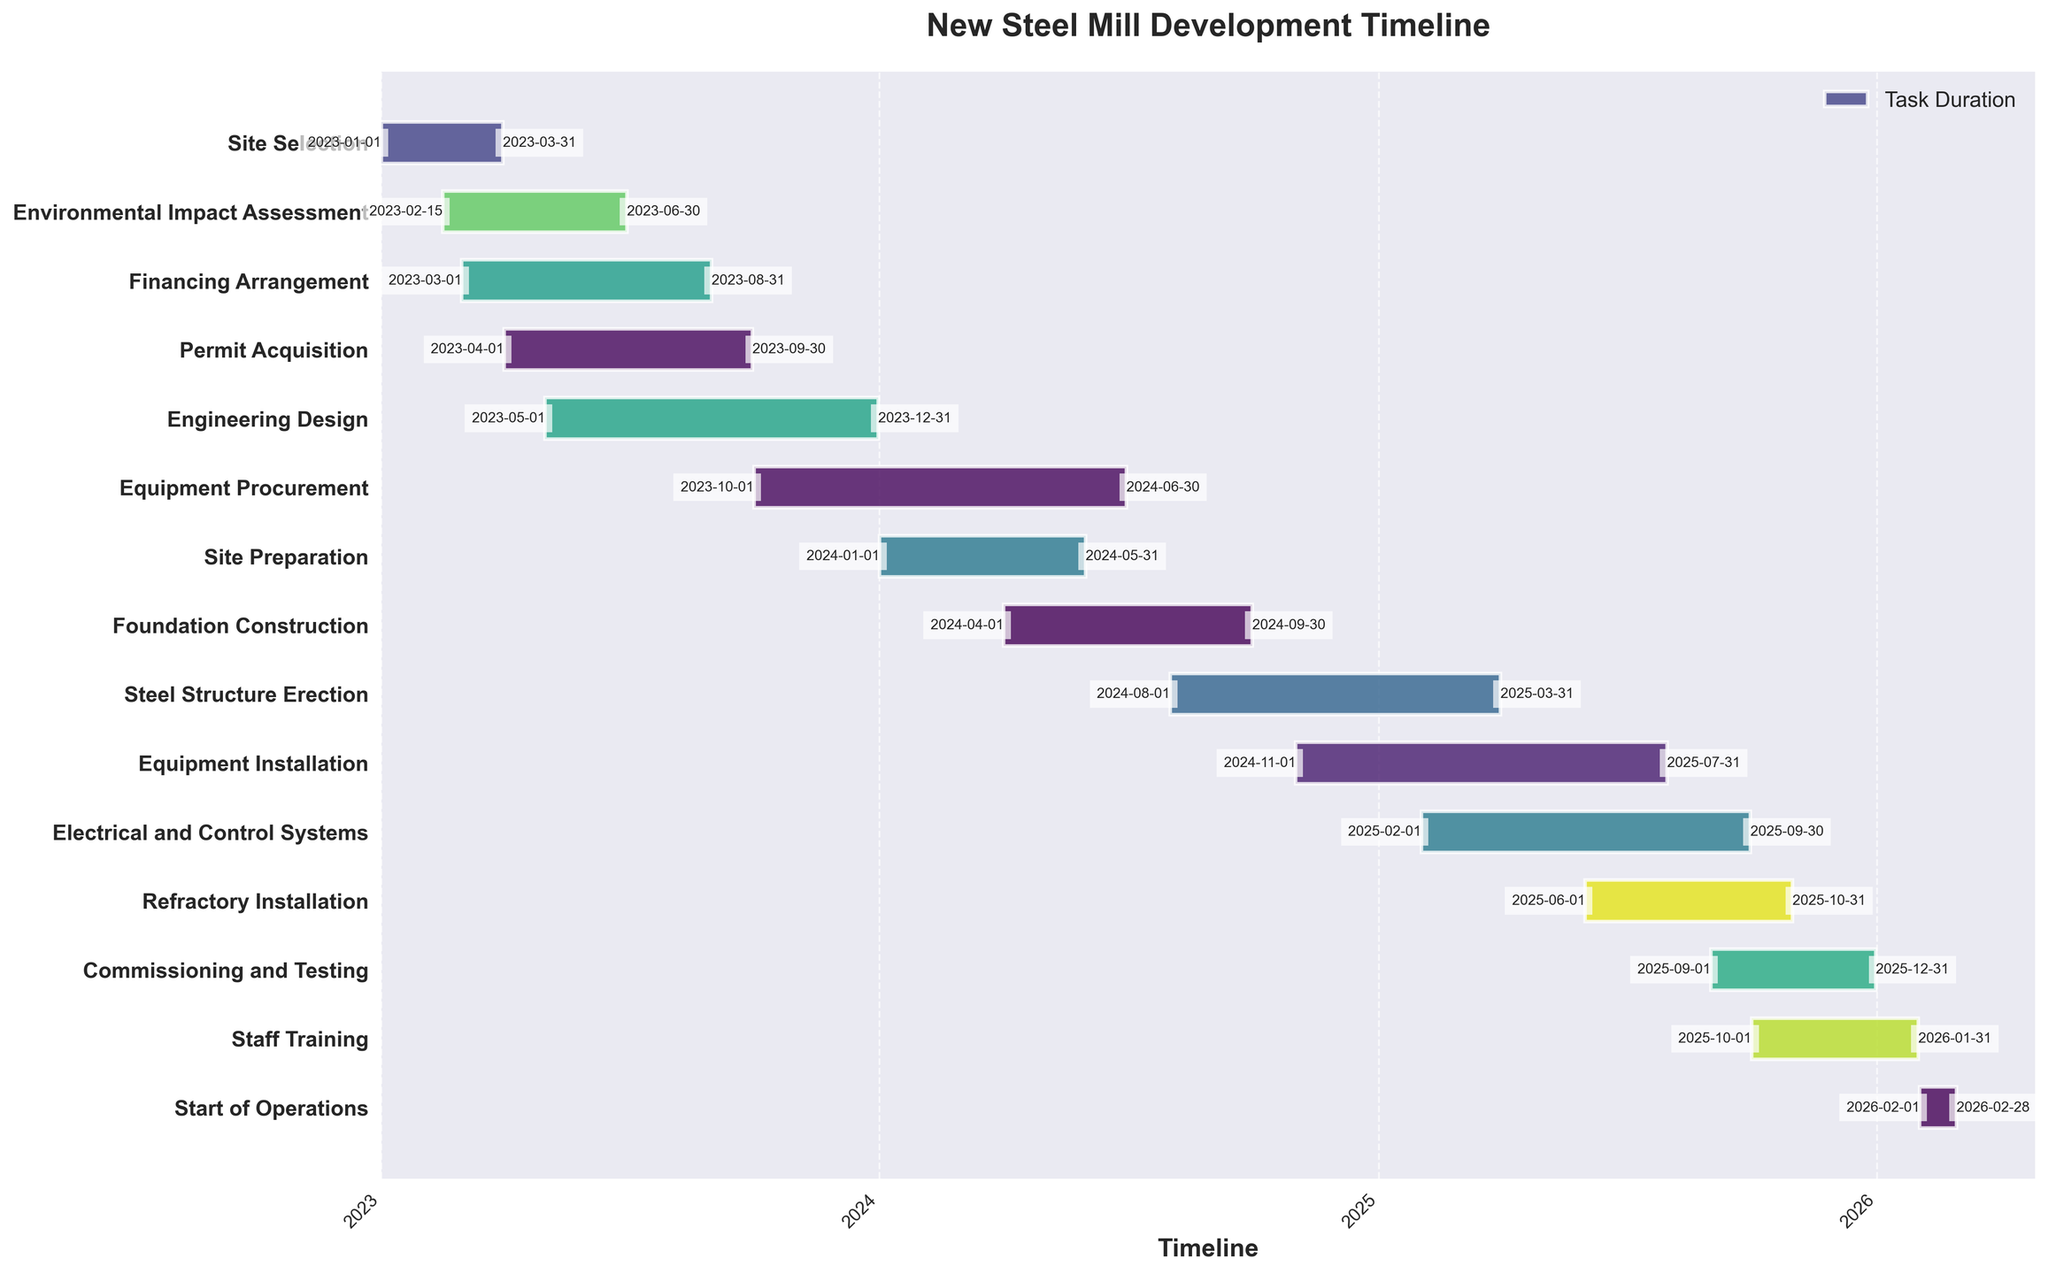what is the title of the chart? The title is generally at the top of the chart. It helps provide an overview of what the chart is about. In this case, it is clear and straightforward.
Answer: New Steel Mill Development Timeline how many tasks are planned between 2025 and 2026? To answer this, look at the tasks that start and end both within and across the years 2025 and 2026.
Answer: 7 which task has the shortest duration? To find this, calculate the duration of each task by subtracting the start date from the end date and identify the task with the smallest result.
Answer: Start of Operations which two tasks overlap for the longest period? Identify tasks that have common dates in their timelines and then calculate the duration of each overlap to find the longest one.
Answer: Commissioning and Testing, and Staff Training when does the Steel Structure Erection task start and end? Locate the Steel Structure Erection task on the y-axis, then read off its start and end dates on the x-axis.
Answer: Starts: 2024-08-01, Ends: 2025-03-31 what is the average duration of tasks that start in 2024? Calculate the duration of each task that starts in 2024 by subtracting the start date from the end date, then find the average of these durations.
Answer: Approximately 6.9 months what task overlaps with Equipment Installation? Identify the timelines of tasks that coincide with the Equipment Installation timeline.
Answer: Electrical and Control Systems which task starts immediately after Equipment Procurement ends? Look for the task that begins on the first date after the Equipment Procurement task ends.
Answer: Site Preparation which task has the longest duration? Compare the durations of all tasks by subtracting the start date from the end date to find the maximum duration.
Answer: Engineering Design how many tasks are there in total? This can be quickly noted by counting the number of tasks listed on the y-axis.
Answer: 14 